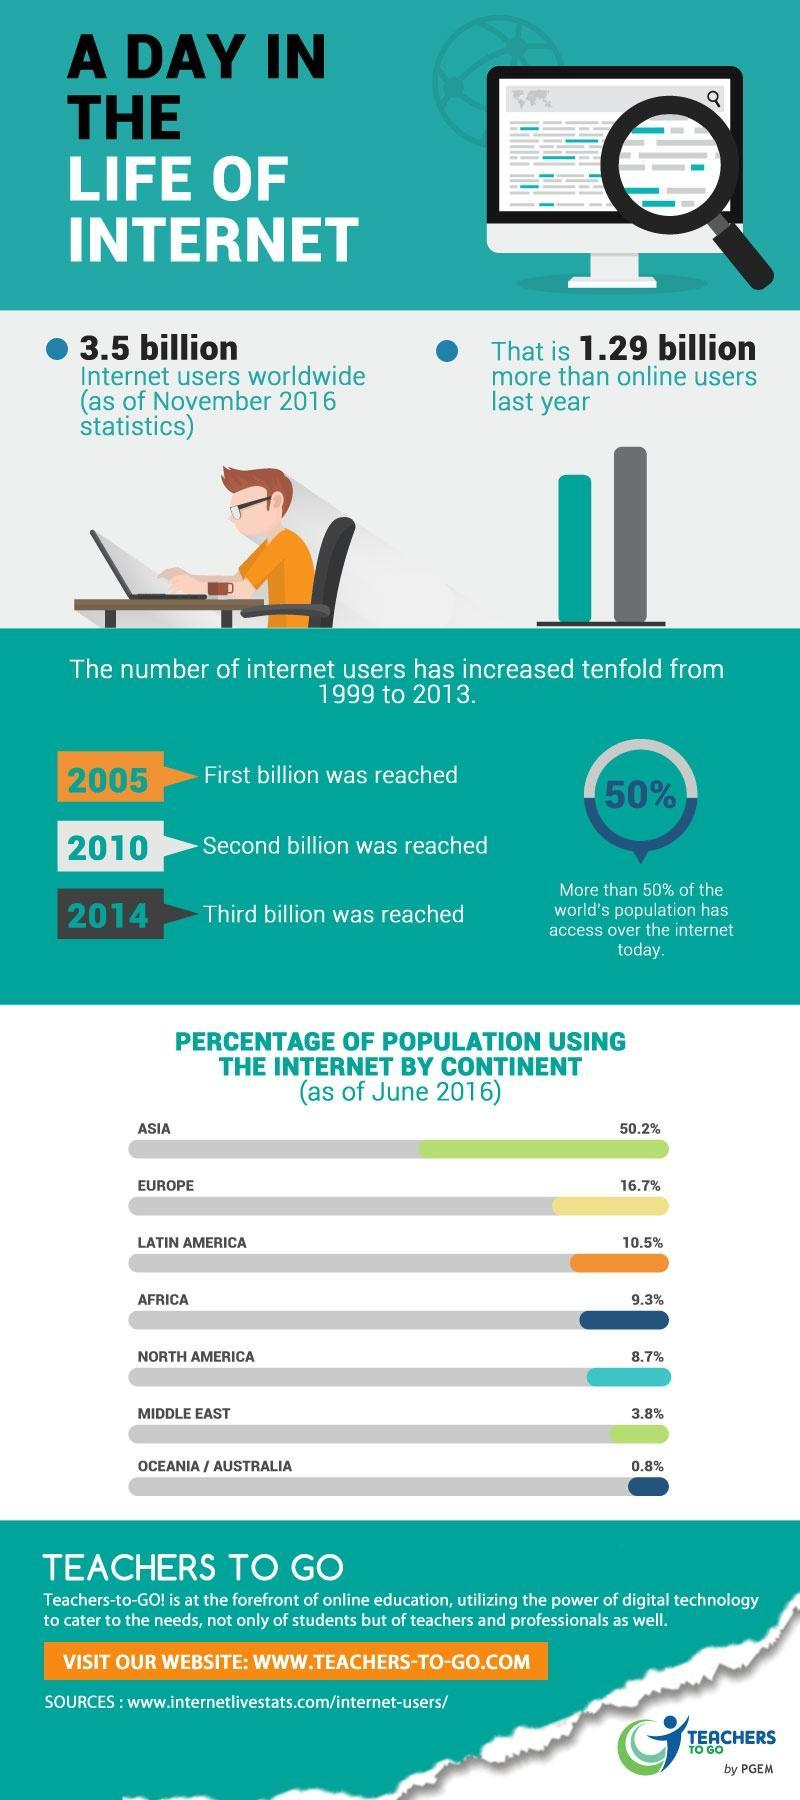What percentage of the population is using the internet in Latin America and Africa, taken together?
Answer the question with a short phrase. 19.8% What percentage of the population is using the internet in the Middle East and Australia, taken together? 4.6% What percentage of the population is using the internet in Africa and North America, taken together? 18% What percentage of the population is using the internet in Asia and Europe, taken together? 66.9% What percentage of the population is using the internet in the Middle East and North America, taken together? 12.5% What percentage of the population is using the internet in Europe and Latin America, taken together? 27.2% 